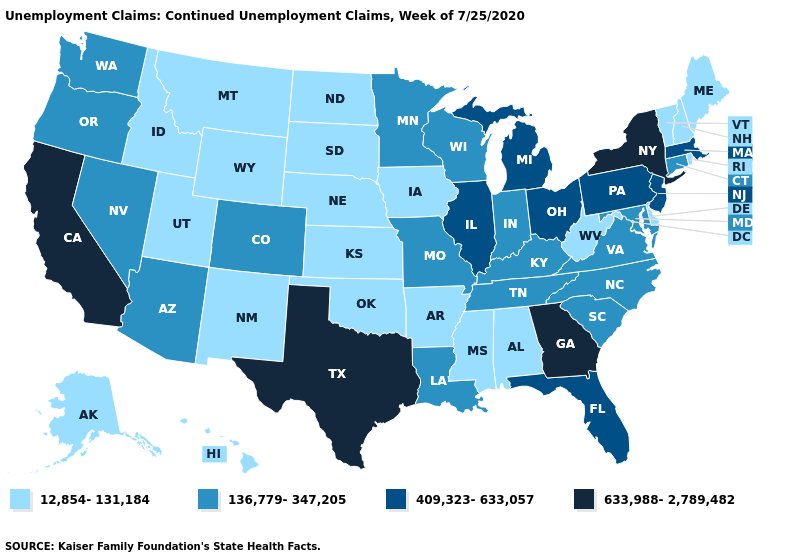Name the states that have a value in the range 12,854-131,184?
Be succinct. Alabama, Alaska, Arkansas, Delaware, Hawaii, Idaho, Iowa, Kansas, Maine, Mississippi, Montana, Nebraska, New Hampshire, New Mexico, North Dakota, Oklahoma, Rhode Island, South Dakota, Utah, Vermont, West Virginia, Wyoming. Which states have the highest value in the USA?
Answer briefly. California, Georgia, New York, Texas. What is the value of Washington?
Concise answer only. 136,779-347,205. What is the value of New Jersey?
Keep it brief. 409,323-633,057. Is the legend a continuous bar?
Give a very brief answer. No. Which states have the lowest value in the West?
Quick response, please. Alaska, Hawaii, Idaho, Montana, New Mexico, Utah, Wyoming. Name the states that have a value in the range 136,779-347,205?
Short answer required. Arizona, Colorado, Connecticut, Indiana, Kentucky, Louisiana, Maryland, Minnesota, Missouri, Nevada, North Carolina, Oregon, South Carolina, Tennessee, Virginia, Washington, Wisconsin. What is the lowest value in the MidWest?
Write a very short answer. 12,854-131,184. Does Illinois have a lower value than California?
Short answer required. Yes. Among the states that border New Hampshire , which have the highest value?
Answer briefly. Massachusetts. Does the first symbol in the legend represent the smallest category?
Concise answer only. Yes. Name the states that have a value in the range 136,779-347,205?
Give a very brief answer. Arizona, Colorado, Connecticut, Indiana, Kentucky, Louisiana, Maryland, Minnesota, Missouri, Nevada, North Carolina, Oregon, South Carolina, Tennessee, Virginia, Washington, Wisconsin. How many symbols are there in the legend?
Give a very brief answer. 4. Which states have the lowest value in the USA?
Quick response, please. Alabama, Alaska, Arkansas, Delaware, Hawaii, Idaho, Iowa, Kansas, Maine, Mississippi, Montana, Nebraska, New Hampshire, New Mexico, North Dakota, Oklahoma, Rhode Island, South Dakota, Utah, Vermont, West Virginia, Wyoming. Name the states that have a value in the range 633,988-2,789,482?
Answer briefly. California, Georgia, New York, Texas. 